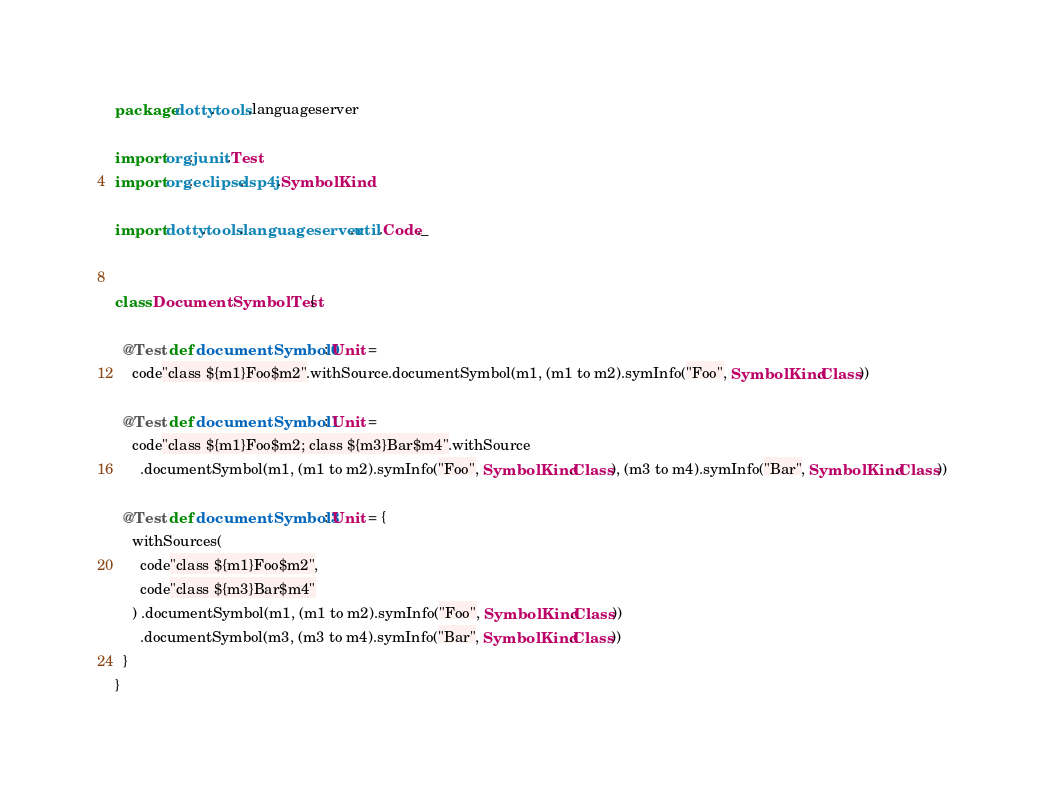<code> <loc_0><loc_0><loc_500><loc_500><_Scala_>package dotty.tools.languageserver

import org.junit.Test
import org.eclipse.lsp4j.SymbolKind

import dotty.tools.languageserver.util.Code._


class DocumentSymbolTest {

  @Test def documentSymbol0: Unit =
    code"class ${m1}Foo$m2".withSource.documentSymbol(m1, (m1 to m2).symInfo("Foo", SymbolKind.Class))

  @Test def documentSymbol1: Unit =
    code"class ${m1}Foo$m2; class ${m3}Bar$m4".withSource
      .documentSymbol(m1, (m1 to m2).symInfo("Foo", SymbolKind.Class), (m3 to m4).symInfo("Bar", SymbolKind.Class))

  @Test def documentSymbol3: Unit = {
    withSources(
      code"class ${m1}Foo$m2",
      code"class ${m3}Bar$m4"
    ) .documentSymbol(m1, (m1 to m2).symInfo("Foo", SymbolKind.Class))
      .documentSymbol(m3, (m3 to m4).symInfo("Bar", SymbolKind.Class))
  }
}
</code> 